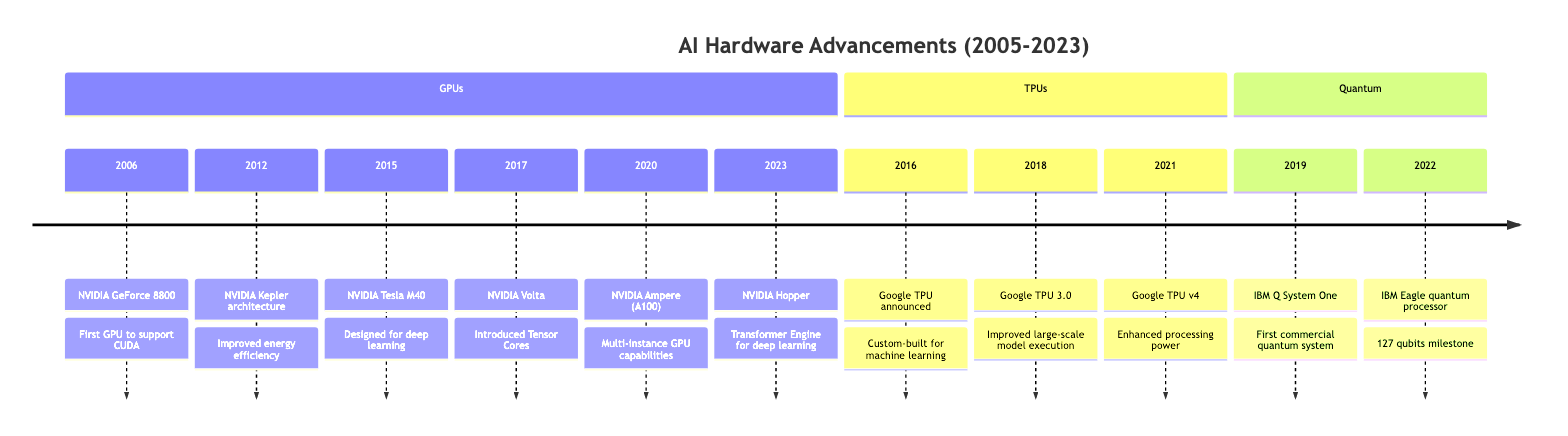What year was the NVIDIA GeForce 8800 released? By looking at the timeline, the first entry under GPUs indicates the release of the NVIDIA GeForce 8800 occurred in the year 2006.
Answer: 2006 Which GPU introduced Tensor Cores? According to the timeline, the entry for NVIDIA Volta in 2017 states that it featured Tensor Cores, answering the question about which GPU had this innovation.
Answer: NVIDIA Volta What significant quantum computing system was announced in 2019? The timeline indicates that in 2019, IBM announced the Q System One, marking its first integrated quantum computing system.
Answer: IBM Q System One How many qubits did IBM's Eagle quantum processor feature? The timeline shows that the IBM Eagle quantum processor, unveiled in 2022, had 127 qubits as highlighted in its details.
Answer: 127 qubits Which TPU version was released in 2021? From the timeline, the section under TPUs notes that Google announced TPU v4 in 2021, specifically listing it.
Answer: TPU v4 What major feature was introduced with NVIDIA's Ampere architecture? The timeline specifies that NVIDIA's Ampere architecture, released in 2020, brought significant performance improvements and included multi-instance GPU capabilities as a key feature.
Answer: Multi-instance GPU capabilities Which hardware development occurred immediately before the release of the NVIDIA Hopper GPUs? By examining the timeline, we can see that the entry for NVIDIA Hopper in 2023 follows the Ampere architecture release in 2020, indicating that the latter was their immediate predecessor.
Answer: NVIDIA Ampere What is the primary design purpose of Google’s Tensor Processing Unit (TPU)? The timeline indicates that Google’s TPU, announced in 2016, was specifically custom-built for machine learning, confirming its primary design purpose.
Answer: Machine learning How many major quantum computing milestones are mentioned in the timeline? By counting the entries under the Quantum section of the timeline, we can see there are two significant milestones: the announcement of the IBM Q System One and the unveiling of the IBM Eagle quantum processor.
Answer: Two 